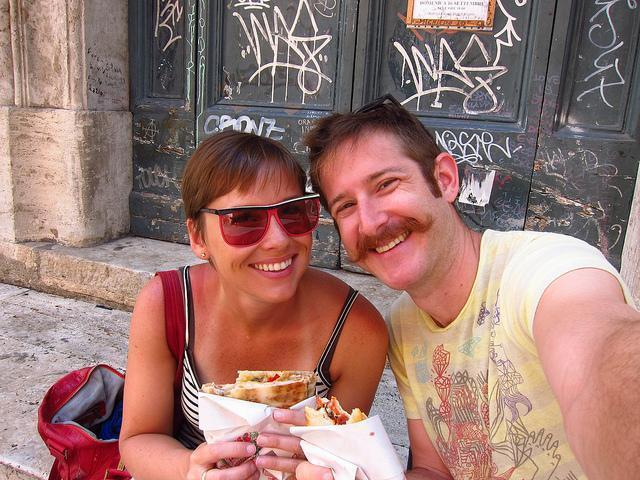Why is she covering her eyes?
Select the correct answer and articulate reasoning with the following format: 'Answer: answer
Rationale: rationale.'
Options: Rain protection, snow protection, ice protection, sun protection. Answer: sun protection.
Rationale: To prevent harmful sun rays or dirt from reaching her eyes. 